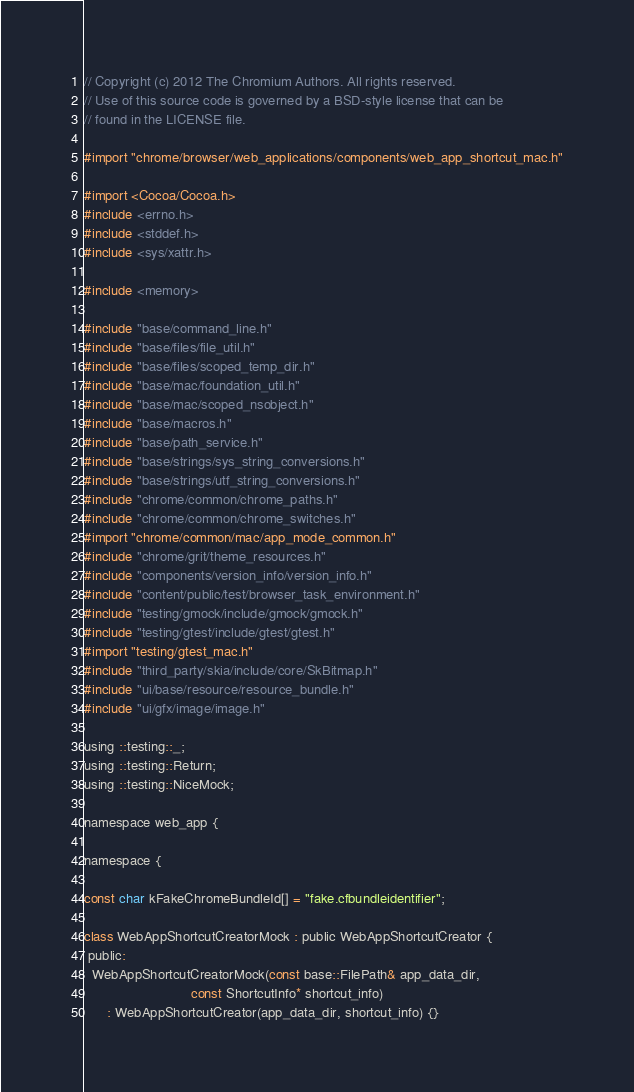Convert code to text. <code><loc_0><loc_0><loc_500><loc_500><_ObjectiveC_>// Copyright (c) 2012 The Chromium Authors. All rights reserved.
// Use of this source code is governed by a BSD-style license that can be
// found in the LICENSE file.

#import "chrome/browser/web_applications/components/web_app_shortcut_mac.h"

#import <Cocoa/Cocoa.h>
#include <errno.h>
#include <stddef.h>
#include <sys/xattr.h>

#include <memory>

#include "base/command_line.h"
#include "base/files/file_util.h"
#include "base/files/scoped_temp_dir.h"
#include "base/mac/foundation_util.h"
#include "base/mac/scoped_nsobject.h"
#include "base/macros.h"
#include "base/path_service.h"
#include "base/strings/sys_string_conversions.h"
#include "base/strings/utf_string_conversions.h"
#include "chrome/common/chrome_paths.h"
#include "chrome/common/chrome_switches.h"
#import "chrome/common/mac/app_mode_common.h"
#include "chrome/grit/theme_resources.h"
#include "components/version_info/version_info.h"
#include "content/public/test/browser_task_environment.h"
#include "testing/gmock/include/gmock/gmock.h"
#include "testing/gtest/include/gtest/gtest.h"
#import "testing/gtest_mac.h"
#include "third_party/skia/include/core/SkBitmap.h"
#include "ui/base/resource/resource_bundle.h"
#include "ui/gfx/image/image.h"

using ::testing::_;
using ::testing::Return;
using ::testing::NiceMock;

namespace web_app {

namespace {

const char kFakeChromeBundleId[] = "fake.cfbundleidentifier";

class WebAppShortcutCreatorMock : public WebAppShortcutCreator {
 public:
  WebAppShortcutCreatorMock(const base::FilePath& app_data_dir,
                            const ShortcutInfo* shortcut_info)
      : WebAppShortcutCreator(app_data_dir, shortcut_info) {}
</code> 